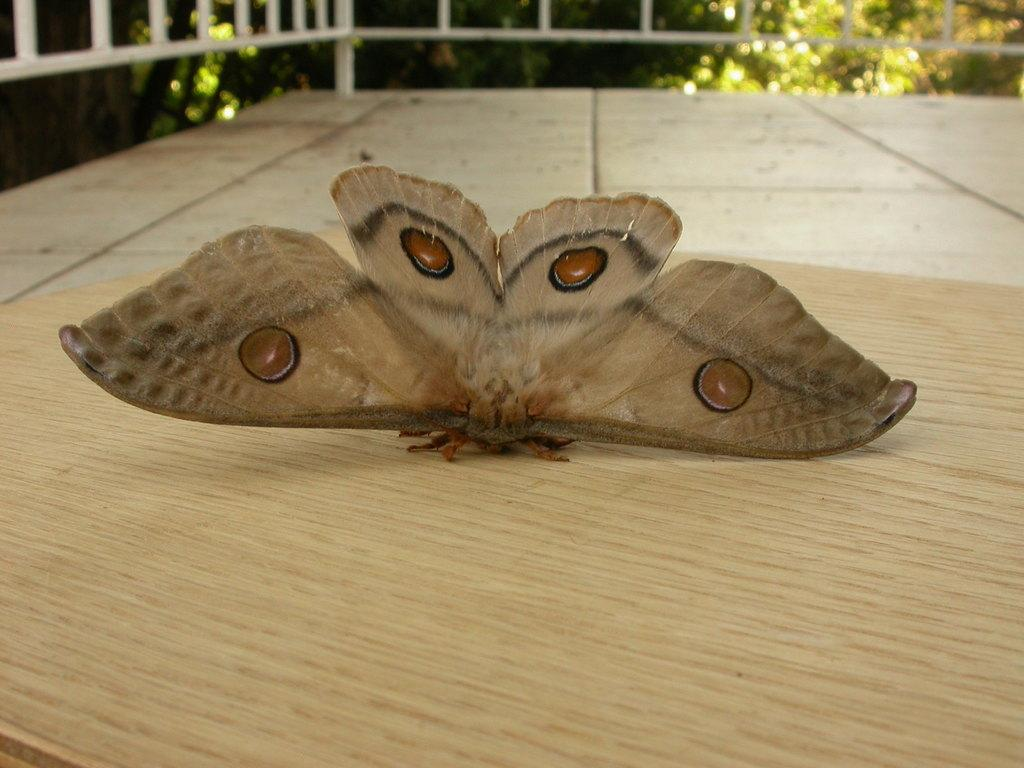What is the main subject of the image? There is a moth in the image. What can be seen in the background of the image? There are plants in the background of the image. How many beads are hanging from the moth's wings in the image? There are no beads present in the image; it features a moth and plants in the background. What type of growth can be seen on the moth's body in the image? There is no growth visible on the moth's body in the image; it is a moth with no additional features mentioned. 